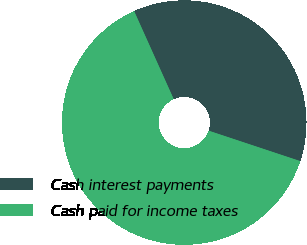Convert chart. <chart><loc_0><loc_0><loc_500><loc_500><pie_chart><fcel>Cash interest payments<fcel>Cash paid for income taxes<nl><fcel>36.83%<fcel>63.17%<nl></chart> 